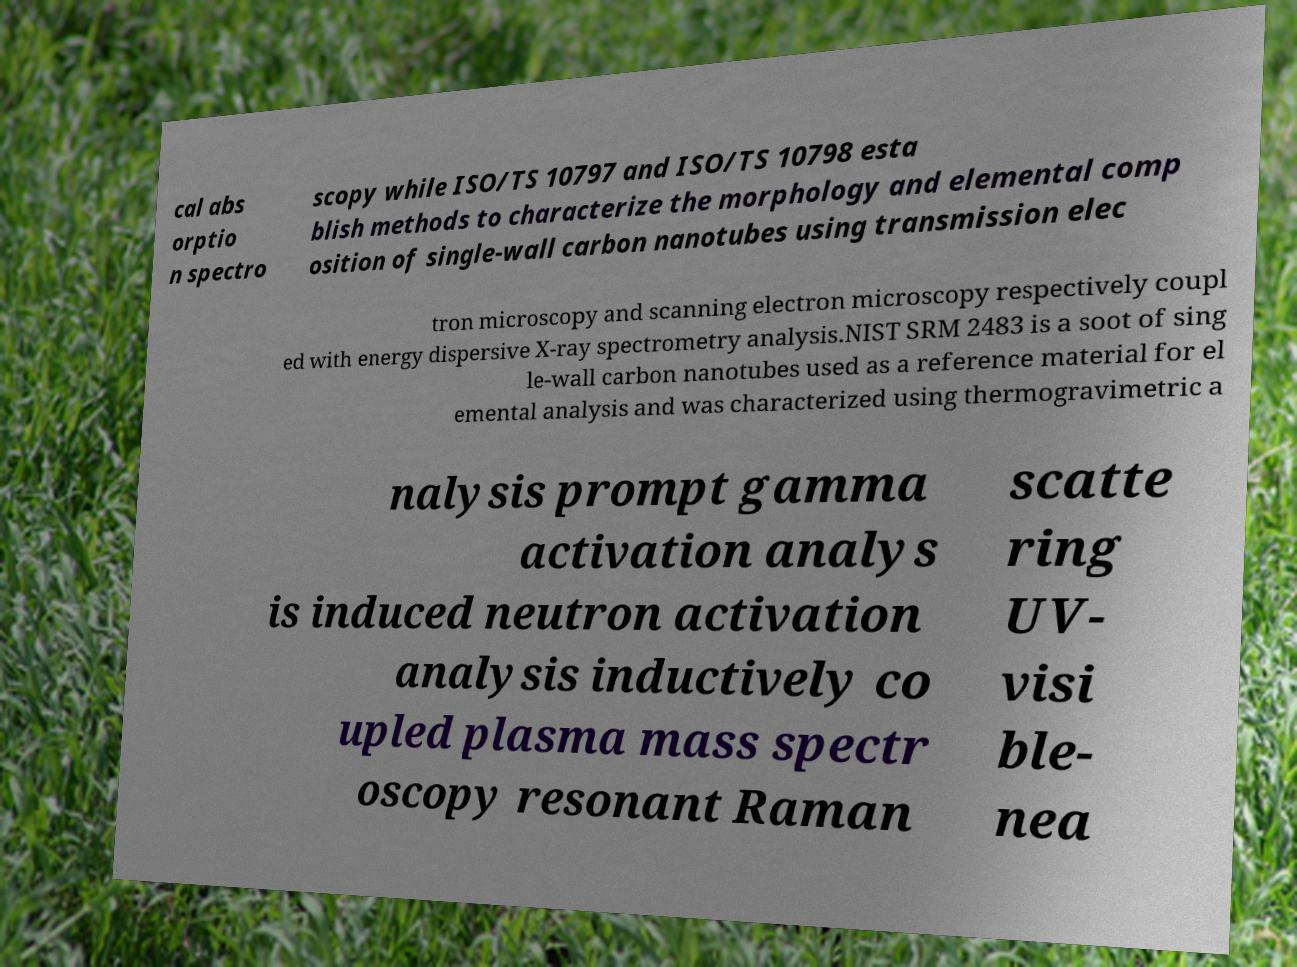Could you extract and type out the text from this image? cal abs orptio n spectro scopy while ISO/TS 10797 and ISO/TS 10798 esta blish methods to characterize the morphology and elemental comp osition of single-wall carbon nanotubes using transmission elec tron microscopy and scanning electron microscopy respectively coupl ed with energy dispersive X-ray spectrometry analysis.NIST SRM 2483 is a soot of sing le-wall carbon nanotubes used as a reference material for el emental analysis and was characterized using thermogravimetric a nalysis prompt gamma activation analys is induced neutron activation analysis inductively co upled plasma mass spectr oscopy resonant Raman scatte ring UV- visi ble- nea 